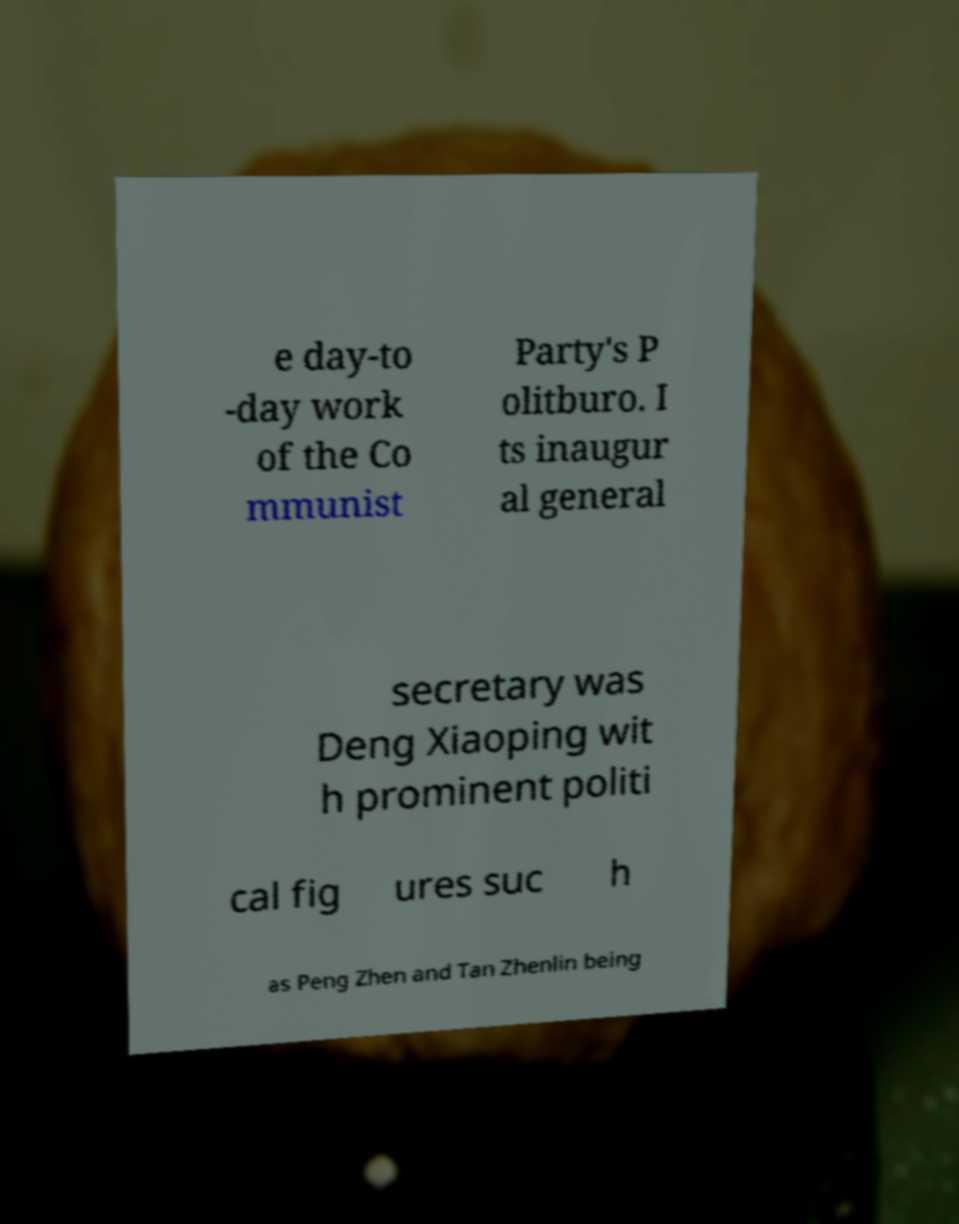Can you read and provide the text displayed in the image?This photo seems to have some interesting text. Can you extract and type it out for me? e day-to -day work of the Co mmunist Party's P olitburo. I ts inaugur al general secretary was Deng Xiaoping wit h prominent politi cal fig ures suc h as Peng Zhen and Tan Zhenlin being 